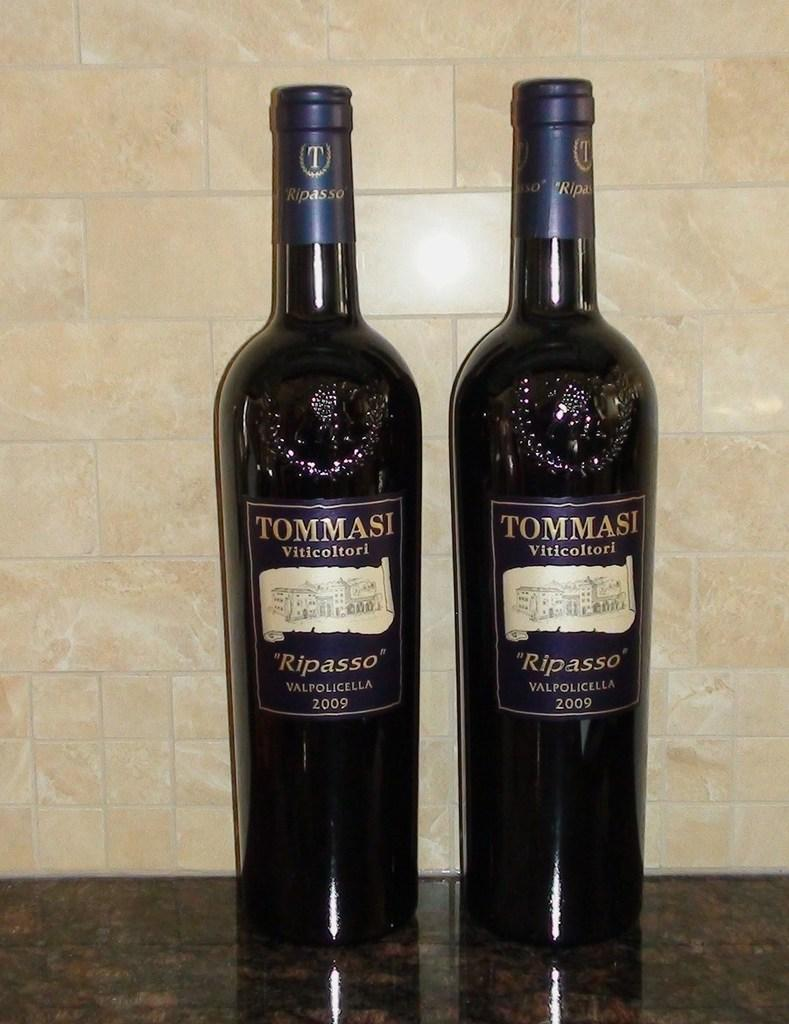<image>
Relay a brief, clear account of the picture shown. The two bottles of wine are made by Tommasi and they are a 2009 vintage. 